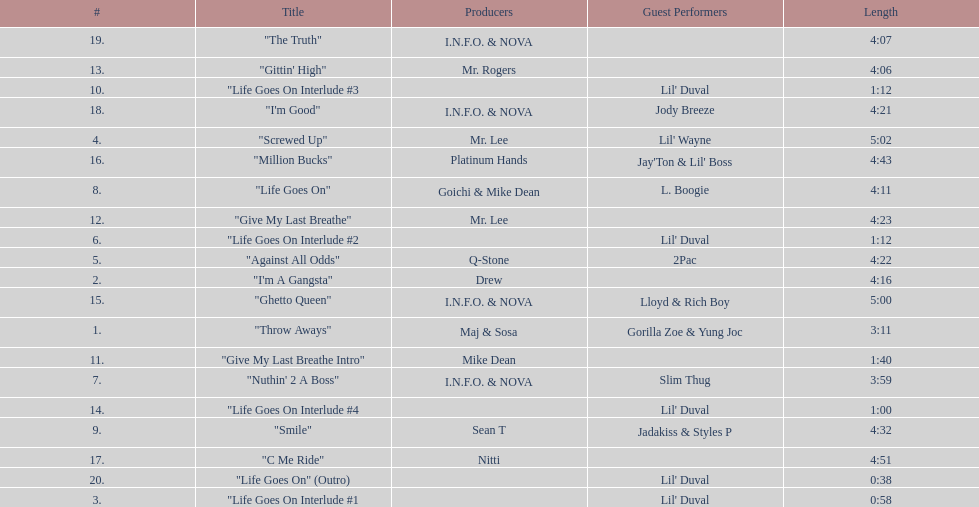What is the last track produced by mr. lee? "Give My Last Breathe". 